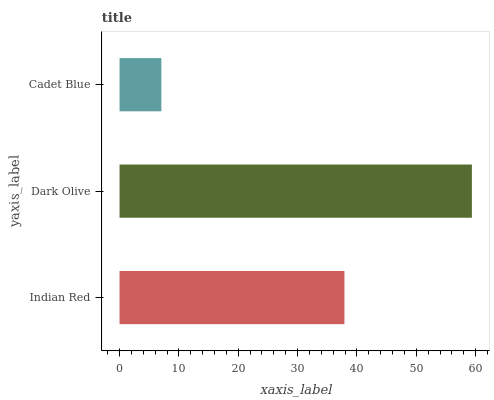Is Cadet Blue the minimum?
Answer yes or no. Yes. Is Dark Olive the maximum?
Answer yes or no. Yes. Is Dark Olive the minimum?
Answer yes or no. No. Is Cadet Blue the maximum?
Answer yes or no. No. Is Dark Olive greater than Cadet Blue?
Answer yes or no. Yes. Is Cadet Blue less than Dark Olive?
Answer yes or no. Yes. Is Cadet Blue greater than Dark Olive?
Answer yes or no. No. Is Dark Olive less than Cadet Blue?
Answer yes or no. No. Is Indian Red the high median?
Answer yes or no. Yes. Is Indian Red the low median?
Answer yes or no. Yes. Is Cadet Blue the high median?
Answer yes or no. No. Is Dark Olive the low median?
Answer yes or no. No. 